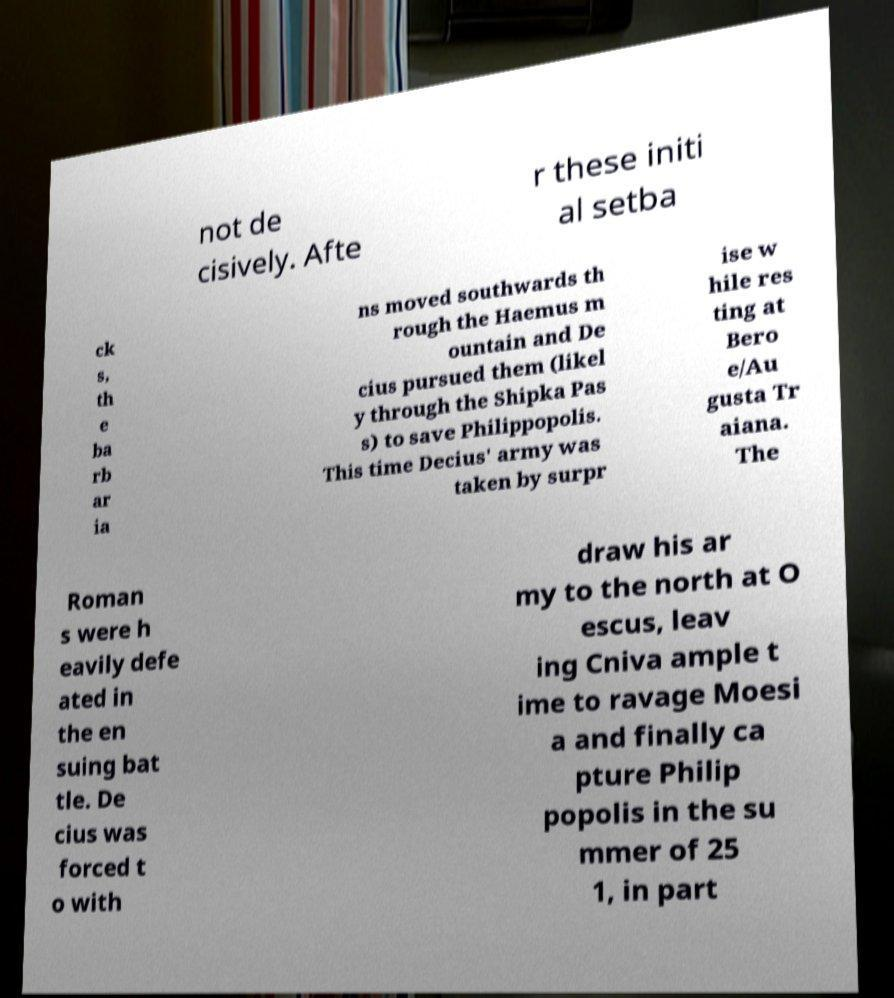Can you read and provide the text displayed in the image?This photo seems to have some interesting text. Can you extract and type it out for me? not de cisively. Afte r these initi al setba ck s, th e ba rb ar ia ns moved southwards th rough the Haemus m ountain and De cius pursued them (likel y through the Shipka Pas s) to save Philippopolis. This time Decius' army was taken by surpr ise w hile res ting at Bero e/Au gusta Tr aiana. The Roman s were h eavily defe ated in the en suing bat tle. De cius was forced t o with draw his ar my to the north at O escus, leav ing Cniva ample t ime to ravage Moesi a and finally ca pture Philip popolis in the su mmer of 25 1, in part 